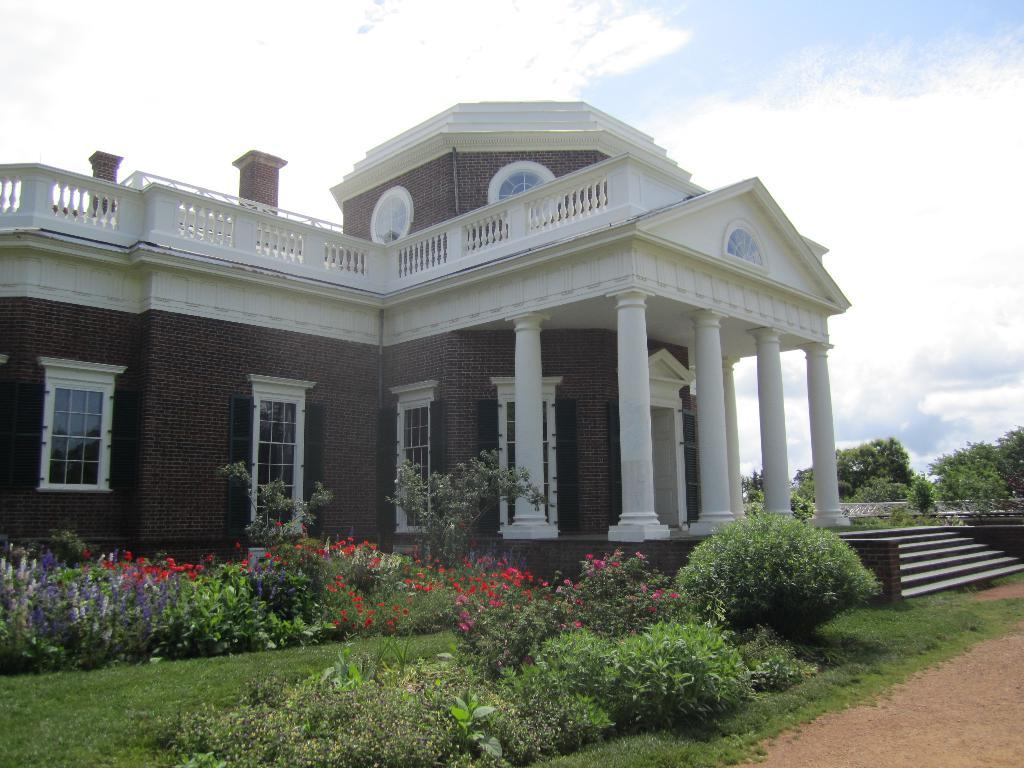What is the main subject in the center of the image? There is a house in the center of the image. What type of vegetation can be seen in the image? There are plants and grass in the image. What is visible in the background of the image? There are clouds in the background of the image. What type of terrain is present on the right side of the image? There is mud on the right side of the image. What is the profit margin of the oil company in the image? There is no mention of an oil company or profit margin in the image. 